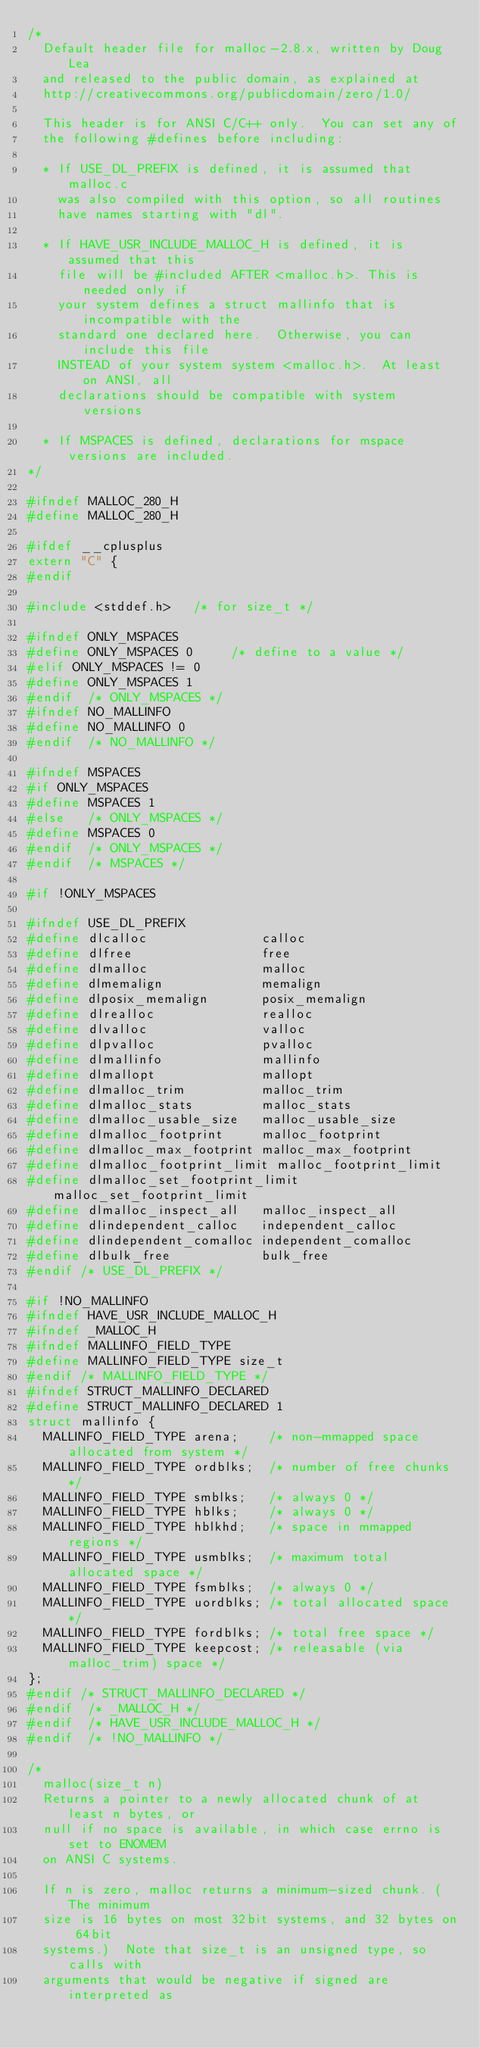<code> <loc_0><loc_0><loc_500><loc_500><_C_>/*
  Default header file for malloc-2.8.x, written by Doug Lea
  and released to the public domain, as explained at
  http://creativecommons.org/publicdomain/zero/1.0/ 
 
  This header is for ANSI C/C++ only.  You can set any of
  the following #defines before including:

  * If USE_DL_PREFIX is defined, it is assumed that malloc.c 
    was also compiled with this option, so all routines
    have names starting with "dl".

  * If HAVE_USR_INCLUDE_MALLOC_H is defined, it is assumed that this
    file will be #included AFTER <malloc.h>. This is needed only if
    your system defines a struct mallinfo that is incompatible with the
    standard one declared here.  Otherwise, you can include this file
    INSTEAD of your system system <malloc.h>.  At least on ANSI, all
    declarations should be compatible with system versions

  * If MSPACES is defined, declarations for mspace versions are included.
*/

#ifndef MALLOC_280_H
#define MALLOC_280_H

#ifdef __cplusplus
extern "C" {
#endif

#include <stddef.h>   /* for size_t */

#ifndef ONLY_MSPACES
#define ONLY_MSPACES 0     /* define to a value */
#elif ONLY_MSPACES != 0
#define ONLY_MSPACES 1
#endif  /* ONLY_MSPACES */
#ifndef NO_MALLINFO
#define NO_MALLINFO 0
#endif  /* NO_MALLINFO */

#ifndef MSPACES
#if ONLY_MSPACES
#define MSPACES 1
#else   /* ONLY_MSPACES */
#define MSPACES 0
#endif  /* ONLY_MSPACES */
#endif  /* MSPACES */

#if !ONLY_MSPACES

#ifndef USE_DL_PREFIX
#define dlcalloc               calloc
#define dlfree                 free
#define dlmalloc               malloc
#define dlmemalign             memalign
#define dlposix_memalign       posix_memalign
#define dlrealloc              realloc
#define dlvalloc               valloc
#define dlpvalloc              pvalloc
#define dlmallinfo             mallinfo
#define dlmallopt              mallopt
#define dlmalloc_trim          malloc_trim
#define dlmalloc_stats         malloc_stats
#define dlmalloc_usable_size   malloc_usable_size
#define dlmalloc_footprint     malloc_footprint
#define dlmalloc_max_footprint malloc_max_footprint
#define dlmalloc_footprint_limit malloc_footprint_limit
#define dlmalloc_set_footprint_limit malloc_set_footprint_limit
#define dlmalloc_inspect_all   malloc_inspect_all
#define dlindependent_calloc   independent_calloc
#define dlindependent_comalloc independent_comalloc
#define dlbulk_free            bulk_free
#endif /* USE_DL_PREFIX */

#if !NO_MALLINFO 
#ifndef HAVE_USR_INCLUDE_MALLOC_H
#ifndef _MALLOC_H
#ifndef MALLINFO_FIELD_TYPE
#define MALLINFO_FIELD_TYPE size_t
#endif /* MALLINFO_FIELD_TYPE */
#ifndef STRUCT_MALLINFO_DECLARED
#define STRUCT_MALLINFO_DECLARED 1
struct mallinfo {
  MALLINFO_FIELD_TYPE arena;    /* non-mmapped space allocated from system */
  MALLINFO_FIELD_TYPE ordblks;  /* number of free chunks */
  MALLINFO_FIELD_TYPE smblks;   /* always 0 */
  MALLINFO_FIELD_TYPE hblks;    /* always 0 */
  MALLINFO_FIELD_TYPE hblkhd;   /* space in mmapped regions */
  MALLINFO_FIELD_TYPE usmblks;  /* maximum total allocated space */
  MALLINFO_FIELD_TYPE fsmblks;  /* always 0 */
  MALLINFO_FIELD_TYPE uordblks; /* total allocated space */
  MALLINFO_FIELD_TYPE fordblks; /* total free space */
  MALLINFO_FIELD_TYPE keepcost; /* releasable (via malloc_trim) space */
};
#endif /* STRUCT_MALLINFO_DECLARED */
#endif  /* _MALLOC_H */
#endif  /* HAVE_USR_INCLUDE_MALLOC_H */
#endif  /* !NO_MALLINFO */

/*
  malloc(size_t n)
  Returns a pointer to a newly allocated chunk of at least n bytes, or
  null if no space is available, in which case errno is set to ENOMEM
  on ANSI C systems.

  If n is zero, malloc returns a minimum-sized chunk. (The minimum
  size is 16 bytes on most 32bit systems, and 32 bytes on 64bit
  systems.)  Note that size_t is an unsigned type, so calls with
  arguments that would be negative if signed are interpreted as</code> 